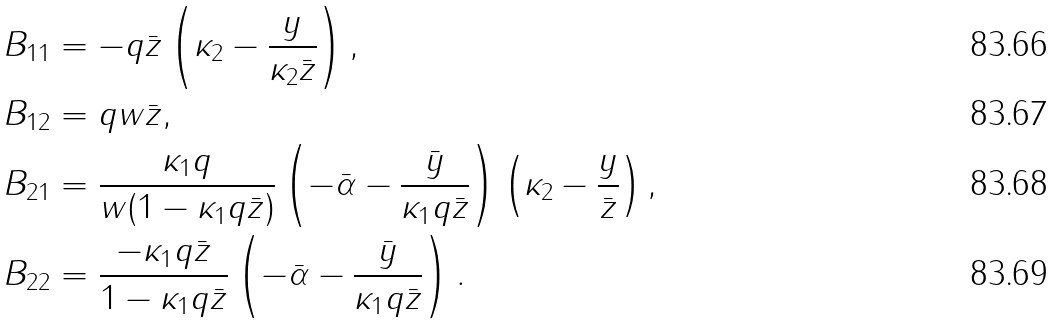<formula> <loc_0><loc_0><loc_500><loc_500>B _ { 1 1 } & = - q \bar { z } \left ( \kappa _ { 2 } - \frac { y } { \kappa _ { 2 } \bar { z } } \right ) , \\ B _ { 1 2 } & = q w \bar { z } , \\ B _ { 2 1 } & = \frac { \kappa _ { 1 } q } { w ( 1 - \kappa _ { 1 } q \bar { z } ) } \left ( - \bar { \alpha } - \frac { \bar { y } } { \kappa _ { 1 } q \bar { z } } \right ) \left ( \kappa _ { 2 } - \frac { y } { \bar { z } } \right ) , \\ B _ { 2 2 } & = \frac { - \kappa _ { 1 } q \bar { z } } { 1 - \kappa _ { 1 } q \bar { z } } \left ( - \bar { \alpha } - \frac { \bar { y } } { \kappa _ { 1 } q \bar { z } } \right ) .</formula> 